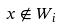Convert formula to latex. <formula><loc_0><loc_0><loc_500><loc_500>x \notin W _ { i }</formula> 